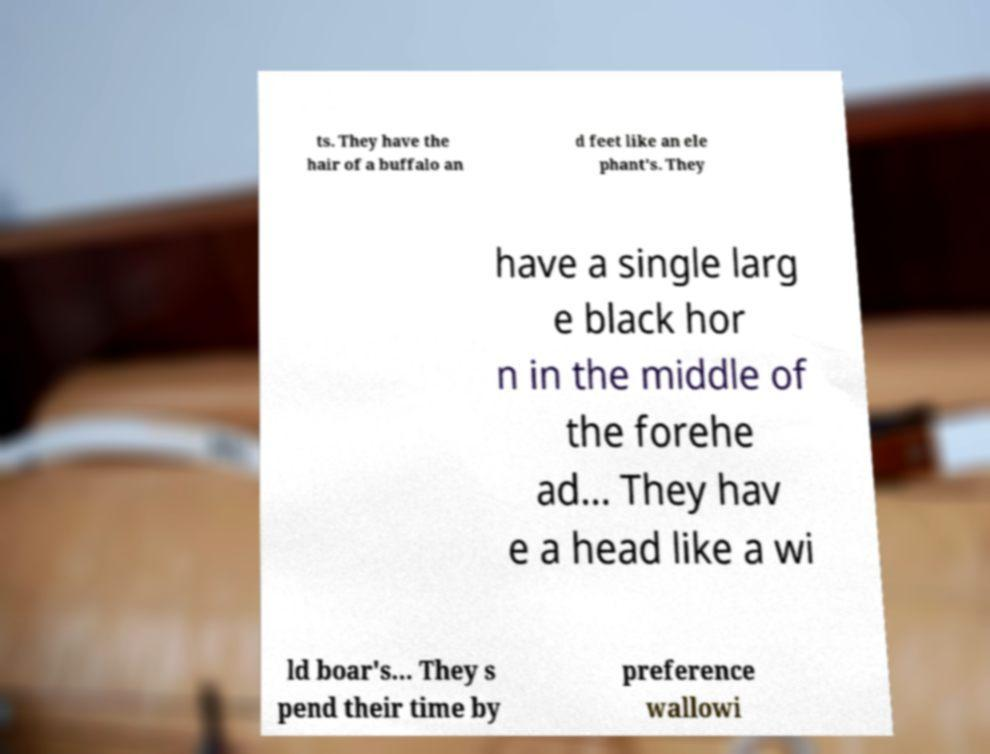Could you assist in decoding the text presented in this image and type it out clearly? ts. They have the hair of a buffalo an d feet like an ele phant's. They have a single larg e black hor n in the middle of the forehe ad... They hav e a head like a wi ld boar's… They s pend their time by preference wallowi 